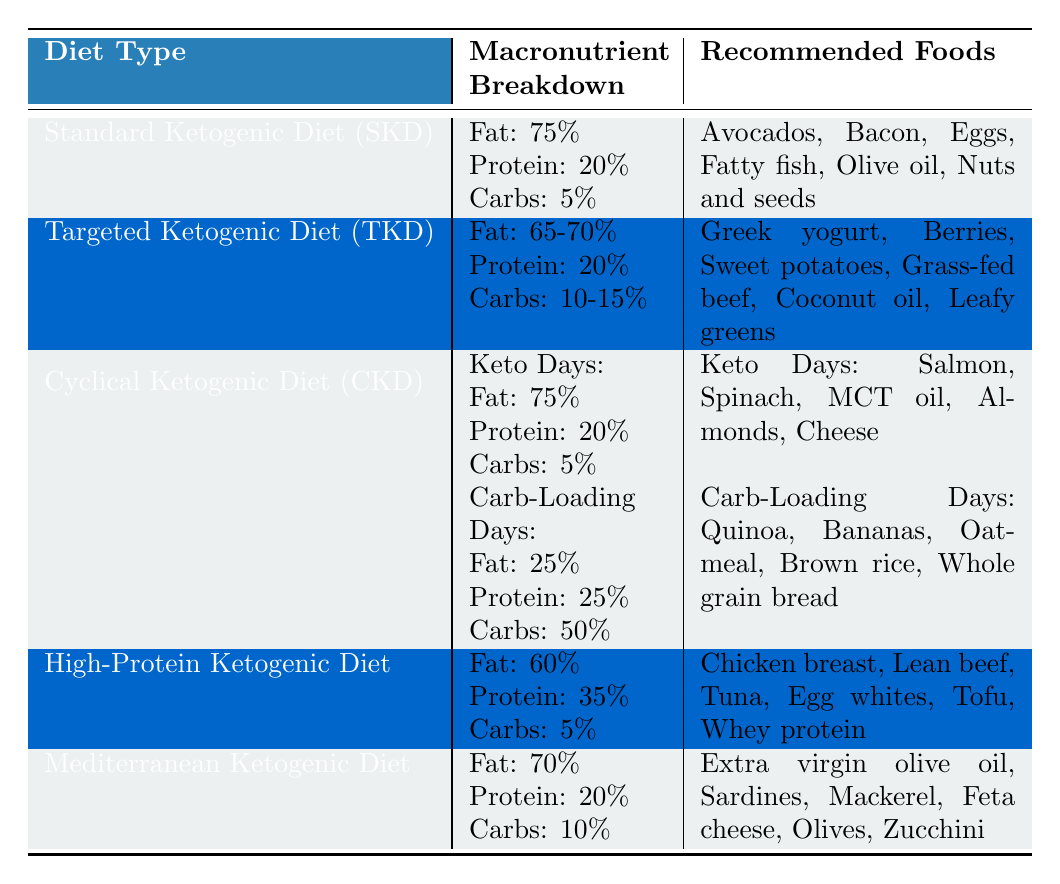What is the macronutrient breakdown for the Standard Ketogenic Diet (SKD)? The table shows that for the Standard Ketogenic Diet, the macronutrient breakdown is Fat: 75%, Protein: 20%, and Carbohydrates: 5%.
Answer: Fat: 75%, Protein: 20%, Carbohydrates: 5% Which ketogenic diet type has the highest percentage of protein? By comparing the macronutrient breakdowns in the table, the High-Protein Ketogenic Diet has 35% protein, which is higher than the others.
Answer: High-Protein Ketogenic Diet What foods are recommended for the Targeted Ketogenic Diet (TKD)? The recommended foods listed for the Targeted Ketogenic Diet in the table include Greek yogurt, Berries, Sweet potatoes, Grass-fed beef, Coconut oil, and Leafy greens.
Answer: Greek yogurt, Berries, Sweet potatoes, Grass-fed beef, Coconut oil, Leafy greens In the Cyclical Ketogenic Diet (CKD), what is the carbohydrate percentage on Carb-Loading Days? The table indicates that on Carb-Loading Days for the CKD, the carbohydrate percentage is 50%.
Answer: 50% Which ketogenic diet type has the lowest carbohydrate percentage, and what is that percentage? The Standard Ketogenic Diet has the lowest carbohydrate percentage at 5%, as shown in the table.
Answer: Standard Ketogenic Diet, 5% What is the average protein percentage across all ketogenic diet types listed? Adding up the protein percentages: 20 + 20 + 20 + 35 + 20 = 115. Since there are 5 diet types, the average protein percentage is 115/5 = 23%.
Answer: 23% Is Extra virgin olive oil recommended in the High-Protein Ketogenic Diet? The table shows that Extra virgin olive oil is listed under the Mediterranean Ketogenic Diet, not the High-Protein Ketogenic Diet. Therefore, the statement is false.
Answer: No For the CKD, how many different foods are recommended on Keto Days? The table lists 5 foods under the Keto Days for the Cyclical Ketogenic Diet: Salmon, Spinach, MCT oil, Almonds, and Cheese.
Answer: 5 foods Which diet type has the highest fat content, and what is that percentage? The Standard Ketogenic Diet and the Cyclical Ketogenic Diet on Keto Days both have the highest fat content at 75%.
Answer: Standard Ketogenic Diet and CKD (Keto Days), 75% What is the food recommended for the Mediterranean Ketogenic Diet that is also a type of fish? The table mentions Sardines and Mackerel as recommended foods for the Mediterranean Ketogenic Diet, both of which are fish.
Answer: Sardines and Mackerel 